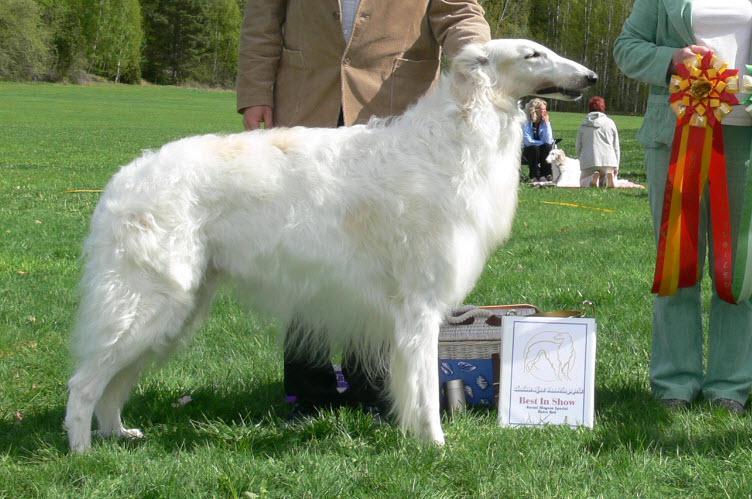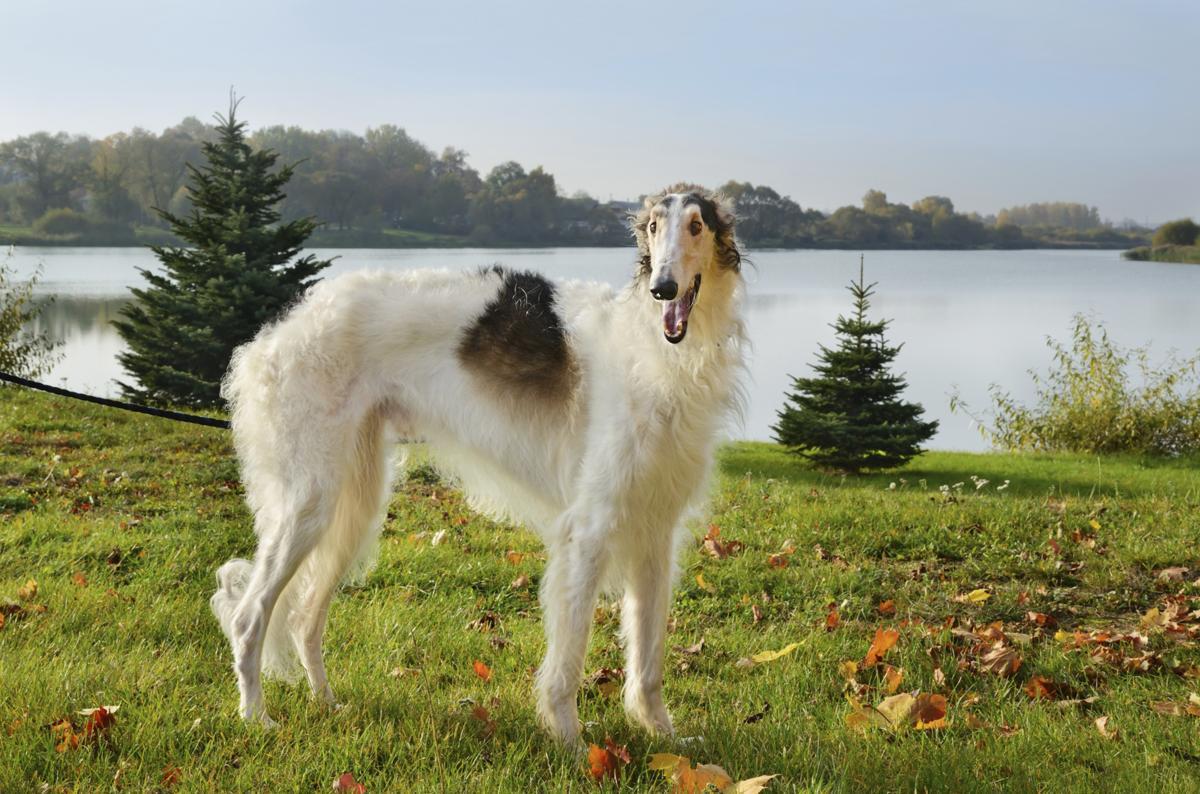The first image is the image on the left, the second image is the image on the right. Evaluate the accuracy of this statement regarding the images: "In both images the dog is turned toward the right side of the image.". Is it true? Answer yes or no. Yes. 